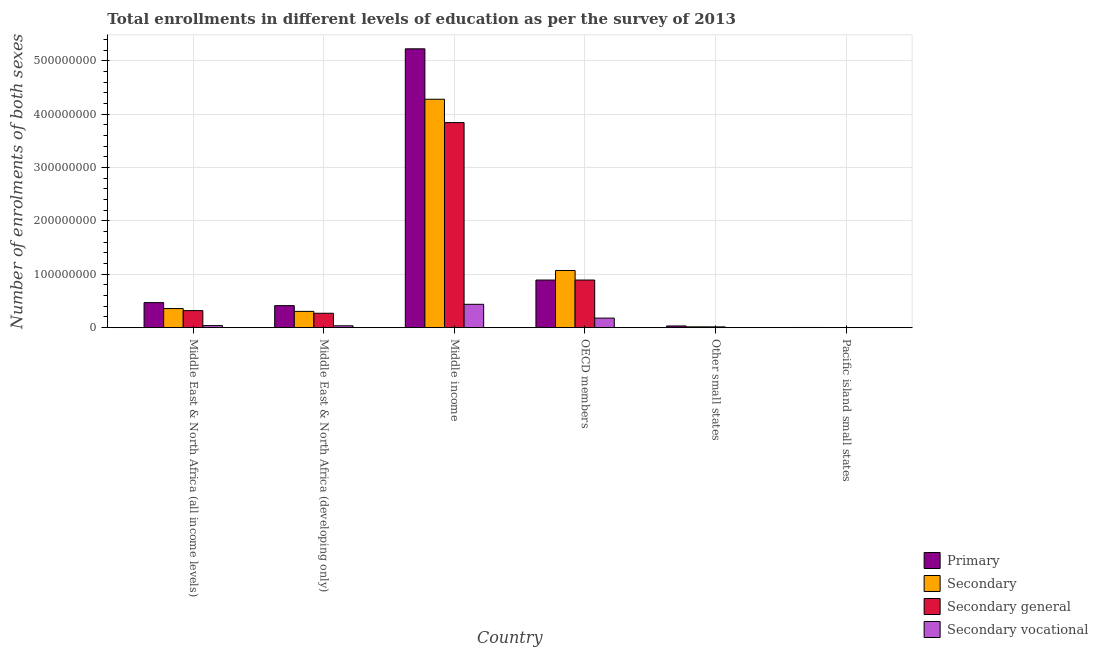Are the number of bars on each tick of the X-axis equal?
Provide a succinct answer. Yes. How many bars are there on the 2nd tick from the right?
Offer a very short reply. 4. In how many cases, is the number of bars for a given country not equal to the number of legend labels?
Offer a very short reply. 0. What is the number of enrolments in secondary vocational education in OECD members?
Ensure brevity in your answer.  1.79e+07. Across all countries, what is the maximum number of enrolments in secondary education?
Offer a very short reply. 4.28e+08. Across all countries, what is the minimum number of enrolments in primary education?
Offer a terse response. 3.38e+05. In which country was the number of enrolments in secondary vocational education maximum?
Your answer should be compact. Middle income. In which country was the number of enrolments in primary education minimum?
Your answer should be very brief. Pacific island small states. What is the total number of enrolments in primary education in the graph?
Offer a very short reply. 7.04e+08. What is the difference between the number of enrolments in secondary general education in Middle East & North Africa (developing only) and that in Middle income?
Provide a succinct answer. -3.57e+08. What is the difference between the number of enrolments in secondary vocational education in Pacific island small states and the number of enrolments in primary education in OECD members?
Your answer should be very brief. -8.93e+07. What is the average number of enrolments in secondary education per country?
Give a very brief answer. 1.01e+08. What is the difference between the number of enrolments in secondary vocational education and number of enrolments in secondary education in Middle East & North Africa (all income levels)?
Keep it short and to the point. -3.20e+07. In how many countries, is the number of enrolments in secondary vocational education greater than 80000000 ?
Your answer should be compact. 0. What is the ratio of the number of enrolments in secondary education in Middle East & North Africa (all income levels) to that in Middle East & North Africa (developing only)?
Your response must be concise. 1.17. Is the difference between the number of enrolments in primary education in Middle East & North Africa (developing only) and Pacific island small states greater than the difference between the number of enrolments in secondary general education in Middle East & North Africa (developing only) and Pacific island small states?
Give a very brief answer. Yes. What is the difference between the highest and the second highest number of enrolments in secondary vocational education?
Offer a very short reply. 2.59e+07. What is the difference between the highest and the lowest number of enrolments in secondary education?
Offer a terse response. 4.28e+08. Is the sum of the number of enrolments in secondary education in Middle East & North Africa (developing only) and Pacific island small states greater than the maximum number of enrolments in secondary vocational education across all countries?
Give a very brief answer. No. What does the 3rd bar from the left in Middle East & North Africa (all income levels) represents?
Provide a succinct answer. Secondary general. What does the 1st bar from the right in Pacific island small states represents?
Offer a terse response. Secondary vocational. Is it the case that in every country, the sum of the number of enrolments in primary education and number of enrolments in secondary education is greater than the number of enrolments in secondary general education?
Your answer should be compact. Yes. What is the difference between two consecutive major ticks on the Y-axis?
Ensure brevity in your answer.  1.00e+08. Are the values on the major ticks of Y-axis written in scientific E-notation?
Provide a succinct answer. No. Does the graph contain any zero values?
Provide a succinct answer. No. Where does the legend appear in the graph?
Provide a succinct answer. Bottom right. How many legend labels are there?
Keep it short and to the point. 4. What is the title of the graph?
Ensure brevity in your answer.  Total enrollments in different levels of education as per the survey of 2013. Does "Miscellaneous expenses" appear as one of the legend labels in the graph?
Your answer should be compact. No. What is the label or title of the X-axis?
Ensure brevity in your answer.  Country. What is the label or title of the Y-axis?
Provide a succinct answer. Number of enrolments of both sexes. What is the Number of enrolments of both sexes in Primary in Middle East & North Africa (all income levels)?
Give a very brief answer. 4.70e+07. What is the Number of enrolments of both sexes of Secondary in Middle East & North Africa (all income levels)?
Your response must be concise. 3.58e+07. What is the Number of enrolments of both sexes in Secondary general in Middle East & North Africa (all income levels)?
Your answer should be compact. 3.20e+07. What is the Number of enrolments of both sexes of Secondary vocational in Middle East & North Africa (all income levels)?
Your answer should be very brief. 3.85e+06. What is the Number of enrolments of both sexes of Primary in Middle East & North Africa (developing only)?
Keep it short and to the point. 4.13e+07. What is the Number of enrolments of both sexes of Secondary in Middle East & North Africa (developing only)?
Provide a succinct answer. 3.05e+07. What is the Number of enrolments of both sexes in Secondary general in Middle East & North Africa (developing only)?
Your answer should be very brief. 2.70e+07. What is the Number of enrolments of both sexes of Secondary vocational in Middle East & North Africa (developing only)?
Your answer should be compact. 3.51e+06. What is the Number of enrolments of both sexes of Primary in Middle income?
Offer a terse response. 5.23e+08. What is the Number of enrolments of both sexes in Secondary in Middle income?
Your answer should be very brief. 4.28e+08. What is the Number of enrolments of both sexes of Secondary general in Middle income?
Your response must be concise. 3.84e+08. What is the Number of enrolments of both sexes in Secondary vocational in Middle income?
Give a very brief answer. 4.38e+07. What is the Number of enrolments of both sexes of Primary in OECD members?
Keep it short and to the point. 8.93e+07. What is the Number of enrolments of both sexes of Secondary in OECD members?
Offer a very short reply. 1.07e+08. What is the Number of enrolments of both sexes in Secondary general in OECD members?
Your answer should be compact. 8.93e+07. What is the Number of enrolments of both sexes of Secondary vocational in OECD members?
Provide a succinct answer. 1.79e+07. What is the Number of enrolments of both sexes in Primary in Other small states?
Your response must be concise. 3.18e+06. What is the Number of enrolments of both sexes of Secondary in Other small states?
Provide a succinct answer. 1.54e+06. What is the Number of enrolments of both sexes of Secondary general in Other small states?
Provide a succinct answer. 1.45e+06. What is the Number of enrolments of both sexes of Secondary vocational in Other small states?
Your answer should be compact. 8.72e+04. What is the Number of enrolments of both sexes in Primary in Pacific island small states?
Keep it short and to the point. 3.38e+05. What is the Number of enrolments of both sexes of Secondary in Pacific island small states?
Your response must be concise. 2.36e+05. What is the Number of enrolments of both sexes of Secondary general in Pacific island small states?
Provide a succinct answer. 2.32e+05. What is the Number of enrolments of both sexes in Secondary vocational in Pacific island small states?
Your answer should be very brief. 4520.05. Across all countries, what is the maximum Number of enrolments of both sexes in Primary?
Your answer should be compact. 5.23e+08. Across all countries, what is the maximum Number of enrolments of both sexes in Secondary?
Your response must be concise. 4.28e+08. Across all countries, what is the maximum Number of enrolments of both sexes in Secondary general?
Your answer should be compact. 3.84e+08. Across all countries, what is the maximum Number of enrolments of both sexes in Secondary vocational?
Offer a very short reply. 4.38e+07. Across all countries, what is the minimum Number of enrolments of both sexes in Primary?
Your answer should be very brief. 3.38e+05. Across all countries, what is the minimum Number of enrolments of both sexes in Secondary?
Keep it short and to the point. 2.36e+05. Across all countries, what is the minimum Number of enrolments of both sexes of Secondary general?
Offer a very short reply. 2.32e+05. Across all countries, what is the minimum Number of enrolments of both sexes in Secondary vocational?
Your response must be concise. 4520.05. What is the total Number of enrolments of both sexes in Primary in the graph?
Your answer should be compact. 7.04e+08. What is the total Number of enrolments of both sexes of Secondary in the graph?
Offer a very short reply. 6.04e+08. What is the total Number of enrolments of both sexes of Secondary general in the graph?
Your answer should be compact. 5.34e+08. What is the total Number of enrolments of both sexes of Secondary vocational in the graph?
Your answer should be very brief. 6.92e+07. What is the difference between the Number of enrolments of both sexes in Primary in Middle East & North Africa (all income levels) and that in Middle East & North Africa (developing only)?
Offer a terse response. 5.65e+06. What is the difference between the Number of enrolments of both sexes in Secondary in Middle East & North Africa (all income levels) and that in Middle East & North Africa (developing only)?
Your answer should be very brief. 5.30e+06. What is the difference between the Number of enrolments of both sexes of Secondary general in Middle East & North Africa (all income levels) and that in Middle East & North Africa (developing only)?
Provide a short and direct response. 4.95e+06. What is the difference between the Number of enrolments of both sexes in Secondary vocational in Middle East & North Africa (all income levels) and that in Middle East & North Africa (developing only)?
Offer a very short reply. 3.45e+05. What is the difference between the Number of enrolments of both sexes in Primary in Middle East & North Africa (all income levels) and that in Middle income?
Your answer should be very brief. -4.76e+08. What is the difference between the Number of enrolments of both sexes of Secondary in Middle East & North Africa (all income levels) and that in Middle income?
Make the answer very short. -3.92e+08. What is the difference between the Number of enrolments of both sexes in Secondary general in Middle East & North Africa (all income levels) and that in Middle income?
Your response must be concise. -3.52e+08. What is the difference between the Number of enrolments of both sexes in Secondary vocational in Middle East & North Africa (all income levels) and that in Middle income?
Provide a succinct answer. -3.99e+07. What is the difference between the Number of enrolments of both sexes in Primary in Middle East & North Africa (all income levels) and that in OECD members?
Keep it short and to the point. -4.23e+07. What is the difference between the Number of enrolments of both sexes in Secondary in Middle East & North Africa (all income levels) and that in OECD members?
Your answer should be compact. -7.14e+07. What is the difference between the Number of enrolments of both sexes of Secondary general in Middle East & North Africa (all income levels) and that in OECD members?
Keep it short and to the point. -5.73e+07. What is the difference between the Number of enrolments of both sexes in Secondary vocational in Middle East & North Africa (all income levels) and that in OECD members?
Your response must be concise. -1.41e+07. What is the difference between the Number of enrolments of both sexes of Primary in Middle East & North Africa (all income levels) and that in Other small states?
Offer a terse response. 4.38e+07. What is the difference between the Number of enrolments of both sexes of Secondary in Middle East & North Africa (all income levels) and that in Other small states?
Make the answer very short. 3.43e+07. What is the difference between the Number of enrolments of both sexes in Secondary general in Middle East & North Africa (all income levels) and that in Other small states?
Your answer should be very brief. 3.05e+07. What is the difference between the Number of enrolments of both sexes in Secondary vocational in Middle East & North Africa (all income levels) and that in Other small states?
Provide a succinct answer. 3.76e+06. What is the difference between the Number of enrolments of both sexes of Primary in Middle East & North Africa (all income levels) and that in Pacific island small states?
Keep it short and to the point. 4.66e+07. What is the difference between the Number of enrolments of both sexes of Secondary in Middle East & North Africa (all income levels) and that in Pacific island small states?
Your response must be concise. 3.56e+07. What is the difference between the Number of enrolments of both sexes of Secondary general in Middle East & North Africa (all income levels) and that in Pacific island small states?
Ensure brevity in your answer.  3.17e+07. What is the difference between the Number of enrolments of both sexes of Secondary vocational in Middle East & North Africa (all income levels) and that in Pacific island small states?
Provide a short and direct response. 3.85e+06. What is the difference between the Number of enrolments of both sexes of Primary in Middle East & North Africa (developing only) and that in Middle income?
Provide a succinct answer. -4.81e+08. What is the difference between the Number of enrolments of both sexes of Secondary in Middle East & North Africa (developing only) and that in Middle income?
Ensure brevity in your answer.  -3.98e+08. What is the difference between the Number of enrolments of both sexes of Secondary general in Middle East & North Africa (developing only) and that in Middle income?
Offer a terse response. -3.57e+08. What is the difference between the Number of enrolments of both sexes of Secondary vocational in Middle East & North Africa (developing only) and that in Middle income?
Your answer should be compact. -4.03e+07. What is the difference between the Number of enrolments of both sexes in Primary in Middle East & North Africa (developing only) and that in OECD members?
Your answer should be very brief. -4.80e+07. What is the difference between the Number of enrolments of both sexes in Secondary in Middle East & North Africa (developing only) and that in OECD members?
Your answer should be very brief. -7.67e+07. What is the difference between the Number of enrolments of both sexes in Secondary general in Middle East & North Africa (developing only) and that in OECD members?
Offer a terse response. -6.23e+07. What is the difference between the Number of enrolments of both sexes in Secondary vocational in Middle East & North Africa (developing only) and that in OECD members?
Offer a very short reply. -1.44e+07. What is the difference between the Number of enrolments of both sexes in Primary in Middle East & North Africa (developing only) and that in Other small states?
Ensure brevity in your answer.  3.81e+07. What is the difference between the Number of enrolments of both sexes in Secondary in Middle East & North Africa (developing only) and that in Other small states?
Offer a very short reply. 2.90e+07. What is the difference between the Number of enrolments of both sexes of Secondary general in Middle East & North Africa (developing only) and that in Other small states?
Your answer should be very brief. 2.56e+07. What is the difference between the Number of enrolments of both sexes of Secondary vocational in Middle East & North Africa (developing only) and that in Other small states?
Your answer should be very brief. 3.42e+06. What is the difference between the Number of enrolments of both sexes in Primary in Middle East & North Africa (developing only) and that in Pacific island small states?
Your response must be concise. 4.10e+07. What is the difference between the Number of enrolments of both sexes of Secondary in Middle East & North Africa (developing only) and that in Pacific island small states?
Ensure brevity in your answer.  3.03e+07. What is the difference between the Number of enrolments of both sexes of Secondary general in Middle East & North Africa (developing only) and that in Pacific island small states?
Offer a terse response. 2.68e+07. What is the difference between the Number of enrolments of both sexes in Secondary vocational in Middle East & North Africa (developing only) and that in Pacific island small states?
Provide a short and direct response. 3.50e+06. What is the difference between the Number of enrolments of both sexes in Primary in Middle income and that in OECD members?
Your response must be concise. 4.33e+08. What is the difference between the Number of enrolments of both sexes in Secondary in Middle income and that in OECD members?
Your answer should be very brief. 3.21e+08. What is the difference between the Number of enrolments of both sexes of Secondary general in Middle income and that in OECD members?
Provide a short and direct response. 2.95e+08. What is the difference between the Number of enrolments of both sexes in Secondary vocational in Middle income and that in OECD members?
Make the answer very short. 2.59e+07. What is the difference between the Number of enrolments of both sexes in Primary in Middle income and that in Other small states?
Make the answer very short. 5.20e+08. What is the difference between the Number of enrolments of both sexes in Secondary in Middle income and that in Other small states?
Keep it short and to the point. 4.27e+08. What is the difference between the Number of enrolments of both sexes of Secondary general in Middle income and that in Other small states?
Ensure brevity in your answer.  3.83e+08. What is the difference between the Number of enrolments of both sexes of Secondary vocational in Middle income and that in Other small states?
Keep it short and to the point. 4.37e+07. What is the difference between the Number of enrolments of both sexes of Primary in Middle income and that in Pacific island small states?
Your answer should be very brief. 5.22e+08. What is the difference between the Number of enrolments of both sexes of Secondary in Middle income and that in Pacific island small states?
Provide a succinct answer. 4.28e+08. What is the difference between the Number of enrolments of both sexes in Secondary general in Middle income and that in Pacific island small states?
Your response must be concise. 3.84e+08. What is the difference between the Number of enrolments of both sexes of Secondary vocational in Middle income and that in Pacific island small states?
Give a very brief answer. 4.38e+07. What is the difference between the Number of enrolments of both sexes of Primary in OECD members and that in Other small states?
Provide a succinct answer. 8.61e+07. What is the difference between the Number of enrolments of both sexes in Secondary in OECD members and that in Other small states?
Your response must be concise. 1.06e+08. What is the difference between the Number of enrolments of both sexes in Secondary general in OECD members and that in Other small states?
Provide a succinct answer. 8.78e+07. What is the difference between the Number of enrolments of both sexes of Secondary vocational in OECD members and that in Other small states?
Ensure brevity in your answer.  1.78e+07. What is the difference between the Number of enrolments of both sexes in Primary in OECD members and that in Pacific island small states?
Give a very brief answer. 8.89e+07. What is the difference between the Number of enrolments of both sexes in Secondary in OECD members and that in Pacific island small states?
Offer a terse response. 1.07e+08. What is the difference between the Number of enrolments of both sexes of Secondary general in OECD members and that in Pacific island small states?
Your answer should be compact. 8.90e+07. What is the difference between the Number of enrolments of both sexes in Secondary vocational in OECD members and that in Pacific island small states?
Provide a succinct answer. 1.79e+07. What is the difference between the Number of enrolments of both sexes in Primary in Other small states and that in Pacific island small states?
Give a very brief answer. 2.85e+06. What is the difference between the Number of enrolments of both sexes of Secondary in Other small states and that in Pacific island small states?
Offer a very short reply. 1.31e+06. What is the difference between the Number of enrolments of both sexes in Secondary general in Other small states and that in Pacific island small states?
Provide a succinct answer. 1.22e+06. What is the difference between the Number of enrolments of both sexes of Secondary vocational in Other small states and that in Pacific island small states?
Give a very brief answer. 8.27e+04. What is the difference between the Number of enrolments of both sexes of Primary in Middle East & North Africa (all income levels) and the Number of enrolments of both sexes of Secondary in Middle East & North Africa (developing only)?
Give a very brief answer. 1.64e+07. What is the difference between the Number of enrolments of both sexes in Primary in Middle East & North Africa (all income levels) and the Number of enrolments of both sexes in Secondary general in Middle East & North Africa (developing only)?
Offer a very short reply. 1.99e+07. What is the difference between the Number of enrolments of both sexes of Primary in Middle East & North Africa (all income levels) and the Number of enrolments of both sexes of Secondary vocational in Middle East & North Africa (developing only)?
Make the answer very short. 4.35e+07. What is the difference between the Number of enrolments of both sexes in Secondary in Middle East & North Africa (all income levels) and the Number of enrolments of both sexes in Secondary general in Middle East & North Africa (developing only)?
Provide a succinct answer. 8.80e+06. What is the difference between the Number of enrolments of both sexes in Secondary in Middle East & North Africa (all income levels) and the Number of enrolments of both sexes in Secondary vocational in Middle East & North Africa (developing only)?
Your response must be concise. 3.23e+07. What is the difference between the Number of enrolments of both sexes in Secondary general in Middle East & North Africa (all income levels) and the Number of enrolments of both sexes in Secondary vocational in Middle East & North Africa (developing only)?
Your response must be concise. 2.85e+07. What is the difference between the Number of enrolments of both sexes in Primary in Middle East & North Africa (all income levels) and the Number of enrolments of both sexes in Secondary in Middle income?
Your answer should be compact. -3.81e+08. What is the difference between the Number of enrolments of both sexes of Primary in Middle East & North Africa (all income levels) and the Number of enrolments of both sexes of Secondary general in Middle income?
Offer a terse response. -3.37e+08. What is the difference between the Number of enrolments of both sexes in Primary in Middle East & North Africa (all income levels) and the Number of enrolments of both sexes in Secondary vocational in Middle income?
Provide a succinct answer. 3.17e+06. What is the difference between the Number of enrolments of both sexes of Secondary in Middle East & North Africa (all income levels) and the Number of enrolments of both sexes of Secondary general in Middle income?
Provide a short and direct response. -3.49e+08. What is the difference between the Number of enrolments of both sexes of Secondary in Middle East & North Africa (all income levels) and the Number of enrolments of both sexes of Secondary vocational in Middle income?
Ensure brevity in your answer.  -7.96e+06. What is the difference between the Number of enrolments of both sexes in Secondary general in Middle East & North Africa (all income levels) and the Number of enrolments of both sexes in Secondary vocational in Middle income?
Provide a succinct answer. -1.18e+07. What is the difference between the Number of enrolments of both sexes in Primary in Middle East & North Africa (all income levels) and the Number of enrolments of both sexes in Secondary in OECD members?
Your answer should be very brief. -6.02e+07. What is the difference between the Number of enrolments of both sexes in Primary in Middle East & North Africa (all income levels) and the Number of enrolments of both sexes in Secondary general in OECD members?
Ensure brevity in your answer.  -4.23e+07. What is the difference between the Number of enrolments of both sexes in Primary in Middle East & North Africa (all income levels) and the Number of enrolments of both sexes in Secondary vocational in OECD members?
Provide a short and direct response. 2.90e+07. What is the difference between the Number of enrolments of both sexes in Secondary in Middle East & North Africa (all income levels) and the Number of enrolments of both sexes in Secondary general in OECD members?
Give a very brief answer. -5.34e+07. What is the difference between the Number of enrolments of both sexes in Secondary in Middle East & North Africa (all income levels) and the Number of enrolments of both sexes in Secondary vocational in OECD members?
Your response must be concise. 1.79e+07. What is the difference between the Number of enrolments of both sexes of Secondary general in Middle East & North Africa (all income levels) and the Number of enrolments of both sexes of Secondary vocational in OECD members?
Offer a terse response. 1.41e+07. What is the difference between the Number of enrolments of both sexes in Primary in Middle East & North Africa (all income levels) and the Number of enrolments of both sexes in Secondary in Other small states?
Your answer should be compact. 4.54e+07. What is the difference between the Number of enrolments of both sexes of Primary in Middle East & North Africa (all income levels) and the Number of enrolments of both sexes of Secondary general in Other small states?
Ensure brevity in your answer.  4.55e+07. What is the difference between the Number of enrolments of both sexes in Primary in Middle East & North Africa (all income levels) and the Number of enrolments of both sexes in Secondary vocational in Other small states?
Make the answer very short. 4.69e+07. What is the difference between the Number of enrolments of both sexes in Secondary in Middle East & North Africa (all income levels) and the Number of enrolments of both sexes in Secondary general in Other small states?
Provide a short and direct response. 3.44e+07. What is the difference between the Number of enrolments of both sexes in Secondary in Middle East & North Africa (all income levels) and the Number of enrolments of both sexes in Secondary vocational in Other small states?
Your answer should be compact. 3.57e+07. What is the difference between the Number of enrolments of both sexes of Secondary general in Middle East & North Africa (all income levels) and the Number of enrolments of both sexes of Secondary vocational in Other small states?
Provide a succinct answer. 3.19e+07. What is the difference between the Number of enrolments of both sexes of Primary in Middle East & North Africa (all income levels) and the Number of enrolments of both sexes of Secondary in Pacific island small states?
Make the answer very short. 4.67e+07. What is the difference between the Number of enrolments of both sexes in Primary in Middle East & North Africa (all income levels) and the Number of enrolments of both sexes in Secondary general in Pacific island small states?
Your answer should be very brief. 4.67e+07. What is the difference between the Number of enrolments of both sexes in Primary in Middle East & North Africa (all income levels) and the Number of enrolments of both sexes in Secondary vocational in Pacific island small states?
Your response must be concise. 4.70e+07. What is the difference between the Number of enrolments of both sexes in Secondary in Middle East & North Africa (all income levels) and the Number of enrolments of both sexes in Secondary general in Pacific island small states?
Offer a terse response. 3.56e+07. What is the difference between the Number of enrolments of both sexes in Secondary in Middle East & North Africa (all income levels) and the Number of enrolments of both sexes in Secondary vocational in Pacific island small states?
Keep it short and to the point. 3.58e+07. What is the difference between the Number of enrolments of both sexes of Secondary general in Middle East & North Africa (all income levels) and the Number of enrolments of both sexes of Secondary vocational in Pacific island small states?
Your answer should be very brief. 3.20e+07. What is the difference between the Number of enrolments of both sexes of Primary in Middle East & North Africa (developing only) and the Number of enrolments of both sexes of Secondary in Middle income?
Provide a short and direct response. -3.87e+08. What is the difference between the Number of enrolments of both sexes in Primary in Middle East & North Africa (developing only) and the Number of enrolments of both sexes in Secondary general in Middle income?
Your response must be concise. -3.43e+08. What is the difference between the Number of enrolments of both sexes in Primary in Middle East & North Africa (developing only) and the Number of enrolments of both sexes in Secondary vocational in Middle income?
Your answer should be very brief. -2.48e+06. What is the difference between the Number of enrolments of both sexes in Secondary in Middle East & North Africa (developing only) and the Number of enrolments of both sexes in Secondary general in Middle income?
Your answer should be very brief. -3.54e+08. What is the difference between the Number of enrolments of both sexes of Secondary in Middle East & North Africa (developing only) and the Number of enrolments of both sexes of Secondary vocational in Middle income?
Give a very brief answer. -1.33e+07. What is the difference between the Number of enrolments of both sexes of Secondary general in Middle East & North Africa (developing only) and the Number of enrolments of both sexes of Secondary vocational in Middle income?
Your answer should be compact. -1.68e+07. What is the difference between the Number of enrolments of both sexes of Primary in Middle East & North Africa (developing only) and the Number of enrolments of both sexes of Secondary in OECD members?
Provide a short and direct response. -6.59e+07. What is the difference between the Number of enrolments of both sexes of Primary in Middle East & North Africa (developing only) and the Number of enrolments of both sexes of Secondary general in OECD members?
Your answer should be compact. -4.80e+07. What is the difference between the Number of enrolments of both sexes in Primary in Middle East & North Africa (developing only) and the Number of enrolments of both sexes in Secondary vocational in OECD members?
Give a very brief answer. 2.34e+07. What is the difference between the Number of enrolments of both sexes of Secondary in Middle East & North Africa (developing only) and the Number of enrolments of both sexes of Secondary general in OECD members?
Give a very brief answer. -5.87e+07. What is the difference between the Number of enrolments of both sexes in Secondary in Middle East & North Africa (developing only) and the Number of enrolments of both sexes in Secondary vocational in OECD members?
Ensure brevity in your answer.  1.26e+07. What is the difference between the Number of enrolments of both sexes of Secondary general in Middle East & North Africa (developing only) and the Number of enrolments of both sexes of Secondary vocational in OECD members?
Provide a short and direct response. 9.10e+06. What is the difference between the Number of enrolments of both sexes of Primary in Middle East & North Africa (developing only) and the Number of enrolments of both sexes of Secondary in Other small states?
Ensure brevity in your answer.  3.98e+07. What is the difference between the Number of enrolments of both sexes in Primary in Middle East & North Africa (developing only) and the Number of enrolments of both sexes in Secondary general in Other small states?
Give a very brief answer. 3.99e+07. What is the difference between the Number of enrolments of both sexes of Primary in Middle East & North Africa (developing only) and the Number of enrolments of both sexes of Secondary vocational in Other small states?
Give a very brief answer. 4.12e+07. What is the difference between the Number of enrolments of both sexes in Secondary in Middle East & North Africa (developing only) and the Number of enrolments of both sexes in Secondary general in Other small states?
Offer a very short reply. 2.91e+07. What is the difference between the Number of enrolments of both sexes of Secondary in Middle East & North Africa (developing only) and the Number of enrolments of both sexes of Secondary vocational in Other small states?
Your response must be concise. 3.04e+07. What is the difference between the Number of enrolments of both sexes of Secondary general in Middle East & North Africa (developing only) and the Number of enrolments of both sexes of Secondary vocational in Other small states?
Provide a short and direct response. 2.69e+07. What is the difference between the Number of enrolments of both sexes of Primary in Middle East & North Africa (developing only) and the Number of enrolments of both sexes of Secondary in Pacific island small states?
Offer a very short reply. 4.11e+07. What is the difference between the Number of enrolments of both sexes in Primary in Middle East & North Africa (developing only) and the Number of enrolments of both sexes in Secondary general in Pacific island small states?
Your answer should be very brief. 4.11e+07. What is the difference between the Number of enrolments of both sexes in Primary in Middle East & North Africa (developing only) and the Number of enrolments of both sexes in Secondary vocational in Pacific island small states?
Offer a terse response. 4.13e+07. What is the difference between the Number of enrolments of both sexes of Secondary in Middle East & North Africa (developing only) and the Number of enrolments of both sexes of Secondary general in Pacific island small states?
Give a very brief answer. 3.03e+07. What is the difference between the Number of enrolments of both sexes of Secondary in Middle East & North Africa (developing only) and the Number of enrolments of both sexes of Secondary vocational in Pacific island small states?
Keep it short and to the point. 3.05e+07. What is the difference between the Number of enrolments of both sexes in Secondary general in Middle East & North Africa (developing only) and the Number of enrolments of both sexes in Secondary vocational in Pacific island small states?
Keep it short and to the point. 2.70e+07. What is the difference between the Number of enrolments of both sexes in Primary in Middle income and the Number of enrolments of both sexes in Secondary in OECD members?
Keep it short and to the point. 4.16e+08. What is the difference between the Number of enrolments of both sexes in Primary in Middle income and the Number of enrolments of both sexes in Secondary general in OECD members?
Your response must be concise. 4.34e+08. What is the difference between the Number of enrolments of both sexes of Primary in Middle income and the Number of enrolments of both sexes of Secondary vocational in OECD members?
Give a very brief answer. 5.05e+08. What is the difference between the Number of enrolments of both sexes in Secondary in Middle income and the Number of enrolments of both sexes in Secondary general in OECD members?
Your response must be concise. 3.39e+08. What is the difference between the Number of enrolments of both sexes of Secondary in Middle income and the Number of enrolments of both sexes of Secondary vocational in OECD members?
Your answer should be very brief. 4.10e+08. What is the difference between the Number of enrolments of both sexes in Secondary general in Middle income and the Number of enrolments of both sexes in Secondary vocational in OECD members?
Offer a terse response. 3.67e+08. What is the difference between the Number of enrolments of both sexes of Primary in Middle income and the Number of enrolments of both sexes of Secondary in Other small states?
Your answer should be compact. 5.21e+08. What is the difference between the Number of enrolments of both sexes of Primary in Middle income and the Number of enrolments of both sexes of Secondary general in Other small states?
Make the answer very short. 5.21e+08. What is the difference between the Number of enrolments of both sexes in Primary in Middle income and the Number of enrolments of both sexes in Secondary vocational in Other small states?
Your response must be concise. 5.23e+08. What is the difference between the Number of enrolments of both sexes of Secondary in Middle income and the Number of enrolments of both sexes of Secondary general in Other small states?
Your answer should be compact. 4.27e+08. What is the difference between the Number of enrolments of both sexes of Secondary in Middle income and the Number of enrolments of both sexes of Secondary vocational in Other small states?
Offer a very short reply. 4.28e+08. What is the difference between the Number of enrolments of both sexes of Secondary general in Middle income and the Number of enrolments of both sexes of Secondary vocational in Other small states?
Provide a short and direct response. 3.84e+08. What is the difference between the Number of enrolments of both sexes in Primary in Middle income and the Number of enrolments of both sexes in Secondary in Pacific island small states?
Keep it short and to the point. 5.23e+08. What is the difference between the Number of enrolments of both sexes in Primary in Middle income and the Number of enrolments of both sexes in Secondary general in Pacific island small states?
Your answer should be compact. 5.23e+08. What is the difference between the Number of enrolments of both sexes in Primary in Middle income and the Number of enrolments of both sexes in Secondary vocational in Pacific island small states?
Make the answer very short. 5.23e+08. What is the difference between the Number of enrolments of both sexes of Secondary in Middle income and the Number of enrolments of both sexes of Secondary general in Pacific island small states?
Your answer should be compact. 4.28e+08. What is the difference between the Number of enrolments of both sexes in Secondary in Middle income and the Number of enrolments of both sexes in Secondary vocational in Pacific island small states?
Provide a succinct answer. 4.28e+08. What is the difference between the Number of enrolments of both sexes in Secondary general in Middle income and the Number of enrolments of both sexes in Secondary vocational in Pacific island small states?
Make the answer very short. 3.84e+08. What is the difference between the Number of enrolments of both sexes in Primary in OECD members and the Number of enrolments of both sexes in Secondary in Other small states?
Offer a terse response. 8.77e+07. What is the difference between the Number of enrolments of both sexes in Primary in OECD members and the Number of enrolments of both sexes in Secondary general in Other small states?
Provide a short and direct response. 8.78e+07. What is the difference between the Number of enrolments of both sexes in Primary in OECD members and the Number of enrolments of both sexes in Secondary vocational in Other small states?
Provide a succinct answer. 8.92e+07. What is the difference between the Number of enrolments of both sexes of Secondary in OECD members and the Number of enrolments of both sexes of Secondary general in Other small states?
Provide a short and direct response. 1.06e+08. What is the difference between the Number of enrolments of both sexes of Secondary in OECD members and the Number of enrolments of both sexes of Secondary vocational in Other small states?
Give a very brief answer. 1.07e+08. What is the difference between the Number of enrolments of both sexes in Secondary general in OECD members and the Number of enrolments of both sexes in Secondary vocational in Other small states?
Offer a very short reply. 8.92e+07. What is the difference between the Number of enrolments of both sexes in Primary in OECD members and the Number of enrolments of both sexes in Secondary in Pacific island small states?
Give a very brief answer. 8.90e+07. What is the difference between the Number of enrolments of both sexes of Primary in OECD members and the Number of enrolments of both sexes of Secondary general in Pacific island small states?
Provide a short and direct response. 8.90e+07. What is the difference between the Number of enrolments of both sexes in Primary in OECD members and the Number of enrolments of both sexes in Secondary vocational in Pacific island small states?
Your answer should be compact. 8.93e+07. What is the difference between the Number of enrolments of both sexes in Secondary in OECD members and the Number of enrolments of both sexes in Secondary general in Pacific island small states?
Provide a succinct answer. 1.07e+08. What is the difference between the Number of enrolments of both sexes in Secondary in OECD members and the Number of enrolments of both sexes in Secondary vocational in Pacific island small states?
Your answer should be compact. 1.07e+08. What is the difference between the Number of enrolments of both sexes of Secondary general in OECD members and the Number of enrolments of both sexes of Secondary vocational in Pacific island small states?
Provide a short and direct response. 8.93e+07. What is the difference between the Number of enrolments of both sexes of Primary in Other small states and the Number of enrolments of both sexes of Secondary in Pacific island small states?
Give a very brief answer. 2.95e+06. What is the difference between the Number of enrolments of both sexes of Primary in Other small states and the Number of enrolments of both sexes of Secondary general in Pacific island small states?
Your answer should be very brief. 2.95e+06. What is the difference between the Number of enrolments of both sexes in Primary in Other small states and the Number of enrolments of both sexes in Secondary vocational in Pacific island small states?
Offer a very short reply. 3.18e+06. What is the difference between the Number of enrolments of both sexes of Secondary in Other small states and the Number of enrolments of both sexes of Secondary general in Pacific island small states?
Ensure brevity in your answer.  1.31e+06. What is the difference between the Number of enrolments of both sexes of Secondary in Other small states and the Number of enrolments of both sexes of Secondary vocational in Pacific island small states?
Provide a succinct answer. 1.54e+06. What is the difference between the Number of enrolments of both sexes in Secondary general in Other small states and the Number of enrolments of both sexes in Secondary vocational in Pacific island small states?
Your answer should be very brief. 1.45e+06. What is the average Number of enrolments of both sexes of Primary per country?
Provide a succinct answer. 1.17e+08. What is the average Number of enrolments of both sexes of Secondary per country?
Provide a short and direct response. 1.01e+08. What is the average Number of enrolments of both sexes in Secondary general per country?
Offer a very short reply. 8.91e+07. What is the average Number of enrolments of both sexes in Secondary vocational per country?
Provide a short and direct response. 1.15e+07. What is the difference between the Number of enrolments of both sexes in Primary and Number of enrolments of both sexes in Secondary in Middle East & North Africa (all income levels)?
Ensure brevity in your answer.  1.11e+07. What is the difference between the Number of enrolments of both sexes of Primary and Number of enrolments of both sexes of Secondary general in Middle East & North Africa (all income levels)?
Make the answer very short. 1.50e+07. What is the difference between the Number of enrolments of both sexes of Primary and Number of enrolments of both sexes of Secondary vocational in Middle East & North Africa (all income levels)?
Offer a terse response. 4.31e+07. What is the difference between the Number of enrolments of both sexes of Secondary and Number of enrolments of both sexes of Secondary general in Middle East & North Africa (all income levels)?
Keep it short and to the point. 3.85e+06. What is the difference between the Number of enrolments of both sexes in Secondary and Number of enrolments of both sexes in Secondary vocational in Middle East & North Africa (all income levels)?
Provide a succinct answer. 3.20e+07. What is the difference between the Number of enrolments of both sexes in Secondary general and Number of enrolments of both sexes in Secondary vocational in Middle East & North Africa (all income levels)?
Your answer should be very brief. 2.81e+07. What is the difference between the Number of enrolments of both sexes in Primary and Number of enrolments of both sexes in Secondary in Middle East & North Africa (developing only)?
Provide a succinct answer. 1.08e+07. What is the difference between the Number of enrolments of both sexes in Primary and Number of enrolments of both sexes in Secondary general in Middle East & North Africa (developing only)?
Give a very brief answer. 1.43e+07. What is the difference between the Number of enrolments of both sexes of Primary and Number of enrolments of both sexes of Secondary vocational in Middle East & North Africa (developing only)?
Offer a terse response. 3.78e+07. What is the difference between the Number of enrolments of both sexes of Secondary and Number of enrolments of both sexes of Secondary general in Middle East & North Africa (developing only)?
Offer a terse response. 3.51e+06. What is the difference between the Number of enrolments of both sexes in Secondary and Number of enrolments of both sexes in Secondary vocational in Middle East & North Africa (developing only)?
Provide a succinct answer. 2.70e+07. What is the difference between the Number of enrolments of both sexes in Secondary general and Number of enrolments of both sexes in Secondary vocational in Middle East & North Africa (developing only)?
Ensure brevity in your answer.  2.35e+07. What is the difference between the Number of enrolments of both sexes of Primary and Number of enrolments of both sexes of Secondary in Middle income?
Your answer should be very brief. 9.45e+07. What is the difference between the Number of enrolments of both sexes in Primary and Number of enrolments of both sexes in Secondary general in Middle income?
Offer a terse response. 1.38e+08. What is the difference between the Number of enrolments of both sexes of Primary and Number of enrolments of both sexes of Secondary vocational in Middle income?
Ensure brevity in your answer.  4.79e+08. What is the difference between the Number of enrolments of both sexes in Secondary and Number of enrolments of both sexes in Secondary general in Middle income?
Your answer should be compact. 4.38e+07. What is the difference between the Number of enrolments of both sexes of Secondary and Number of enrolments of both sexes of Secondary vocational in Middle income?
Provide a short and direct response. 3.84e+08. What is the difference between the Number of enrolments of both sexes in Secondary general and Number of enrolments of both sexes in Secondary vocational in Middle income?
Keep it short and to the point. 3.41e+08. What is the difference between the Number of enrolments of both sexes in Primary and Number of enrolments of both sexes in Secondary in OECD members?
Offer a very short reply. -1.79e+07. What is the difference between the Number of enrolments of both sexes in Primary and Number of enrolments of both sexes in Secondary general in OECD members?
Ensure brevity in your answer.  3752. What is the difference between the Number of enrolments of both sexes of Primary and Number of enrolments of both sexes of Secondary vocational in OECD members?
Your response must be concise. 7.14e+07. What is the difference between the Number of enrolments of both sexes in Secondary and Number of enrolments of both sexes in Secondary general in OECD members?
Offer a terse response. 1.79e+07. What is the difference between the Number of enrolments of both sexes in Secondary and Number of enrolments of both sexes in Secondary vocational in OECD members?
Your answer should be very brief. 8.93e+07. What is the difference between the Number of enrolments of both sexes of Secondary general and Number of enrolments of both sexes of Secondary vocational in OECD members?
Your response must be concise. 7.14e+07. What is the difference between the Number of enrolments of both sexes of Primary and Number of enrolments of both sexes of Secondary in Other small states?
Make the answer very short. 1.64e+06. What is the difference between the Number of enrolments of both sexes of Primary and Number of enrolments of both sexes of Secondary general in Other small states?
Offer a very short reply. 1.73e+06. What is the difference between the Number of enrolments of both sexes of Primary and Number of enrolments of both sexes of Secondary vocational in Other small states?
Provide a short and direct response. 3.10e+06. What is the difference between the Number of enrolments of both sexes of Secondary and Number of enrolments of both sexes of Secondary general in Other small states?
Your response must be concise. 8.72e+04. What is the difference between the Number of enrolments of both sexes of Secondary and Number of enrolments of both sexes of Secondary vocational in Other small states?
Give a very brief answer. 1.45e+06. What is the difference between the Number of enrolments of both sexes of Secondary general and Number of enrolments of both sexes of Secondary vocational in Other small states?
Ensure brevity in your answer.  1.37e+06. What is the difference between the Number of enrolments of both sexes in Primary and Number of enrolments of both sexes in Secondary in Pacific island small states?
Give a very brief answer. 1.02e+05. What is the difference between the Number of enrolments of both sexes of Primary and Number of enrolments of both sexes of Secondary general in Pacific island small states?
Your answer should be compact. 1.06e+05. What is the difference between the Number of enrolments of both sexes of Primary and Number of enrolments of both sexes of Secondary vocational in Pacific island small states?
Keep it short and to the point. 3.34e+05. What is the difference between the Number of enrolments of both sexes in Secondary and Number of enrolments of both sexes in Secondary general in Pacific island small states?
Keep it short and to the point. 4520.06. What is the difference between the Number of enrolments of both sexes in Secondary and Number of enrolments of both sexes in Secondary vocational in Pacific island small states?
Your answer should be very brief. 2.32e+05. What is the difference between the Number of enrolments of both sexes of Secondary general and Number of enrolments of both sexes of Secondary vocational in Pacific island small states?
Your answer should be compact. 2.27e+05. What is the ratio of the Number of enrolments of both sexes of Primary in Middle East & North Africa (all income levels) to that in Middle East & North Africa (developing only)?
Make the answer very short. 1.14. What is the ratio of the Number of enrolments of both sexes in Secondary in Middle East & North Africa (all income levels) to that in Middle East & North Africa (developing only)?
Your answer should be compact. 1.17. What is the ratio of the Number of enrolments of both sexes of Secondary general in Middle East & North Africa (all income levels) to that in Middle East & North Africa (developing only)?
Offer a very short reply. 1.18. What is the ratio of the Number of enrolments of both sexes of Secondary vocational in Middle East & North Africa (all income levels) to that in Middle East & North Africa (developing only)?
Offer a terse response. 1.1. What is the ratio of the Number of enrolments of both sexes in Primary in Middle East & North Africa (all income levels) to that in Middle income?
Your answer should be compact. 0.09. What is the ratio of the Number of enrolments of both sexes of Secondary in Middle East & North Africa (all income levels) to that in Middle income?
Offer a terse response. 0.08. What is the ratio of the Number of enrolments of both sexes in Secondary general in Middle East & North Africa (all income levels) to that in Middle income?
Offer a very short reply. 0.08. What is the ratio of the Number of enrolments of both sexes in Secondary vocational in Middle East & North Africa (all income levels) to that in Middle income?
Your answer should be compact. 0.09. What is the ratio of the Number of enrolments of both sexes in Primary in Middle East & North Africa (all income levels) to that in OECD members?
Ensure brevity in your answer.  0.53. What is the ratio of the Number of enrolments of both sexes of Secondary in Middle East & North Africa (all income levels) to that in OECD members?
Keep it short and to the point. 0.33. What is the ratio of the Number of enrolments of both sexes in Secondary general in Middle East & North Africa (all income levels) to that in OECD members?
Provide a succinct answer. 0.36. What is the ratio of the Number of enrolments of both sexes of Secondary vocational in Middle East & North Africa (all income levels) to that in OECD members?
Provide a succinct answer. 0.21. What is the ratio of the Number of enrolments of both sexes in Primary in Middle East & North Africa (all income levels) to that in Other small states?
Offer a terse response. 14.75. What is the ratio of the Number of enrolments of both sexes of Secondary in Middle East & North Africa (all income levels) to that in Other small states?
Ensure brevity in your answer.  23.24. What is the ratio of the Number of enrolments of both sexes of Secondary general in Middle East & North Africa (all income levels) to that in Other small states?
Make the answer very short. 21.98. What is the ratio of the Number of enrolments of both sexes in Secondary vocational in Middle East & North Africa (all income levels) to that in Other small states?
Your answer should be very brief. 44.15. What is the ratio of the Number of enrolments of both sexes of Primary in Middle East & North Africa (all income levels) to that in Pacific island small states?
Keep it short and to the point. 138.82. What is the ratio of the Number of enrolments of both sexes in Secondary in Middle East & North Africa (all income levels) to that in Pacific island small states?
Ensure brevity in your answer.  151.51. What is the ratio of the Number of enrolments of both sexes in Secondary general in Middle East & North Africa (all income levels) to that in Pacific island small states?
Ensure brevity in your answer.  137.85. What is the ratio of the Number of enrolments of both sexes in Secondary vocational in Middle East & North Africa (all income levels) to that in Pacific island small states?
Your response must be concise. 852.06. What is the ratio of the Number of enrolments of both sexes in Primary in Middle East & North Africa (developing only) to that in Middle income?
Your response must be concise. 0.08. What is the ratio of the Number of enrolments of both sexes in Secondary in Middle East & North Africa (developing only) to that in Middle income?
Your answer should be compact. 0.07. What is the ratio of the Number of enrolments of both sexes of Secondary general in Middle East & North Africa (developing only) to that in Middle income?
Ensure brevity in your answer.  0.07. What is the ratio of the Number of enrolments of both sexes in Secondary vocational in Middle East & North Africa (developing only) to that in Middle income?
Your answer should be very brief. 0.08. What is the ratio of the Number of enrolments of both sexes of Primary in Middle East & North Africa (developing only) to that in OECD members?
Offer a terse response. 0.46. What is the ratio of the Number of enrolments of both sexes in Secondary in Middle East & North Africa (developing only) to that in OECD members?
Your response must be concise. 0.28. What is the ratio of the Number of enrolments of both sexes of Secondary general in Middle East & North Africa (developing only) to that in OECD members?
Your response must be concise. 0.3. What is the ratio of the Number of enrolments of both sexes of Secondary vocational in Middle East & North Africa (developing only) to that in OECD members?
Provide a succinct answer. 0.2. What is the ratio of the Number of enrolments of both sexes of Primary in Middle East & North Africa (developing only) to that in Other small states?
Ensure brevity in your answer.  12.97. What is the ratio of the Number of enrolments of both sexes of Secondary in Middle East & North Africa (developing only) to that in Other small states?
Ensure brevity in your answer.  19.8. What is the ratio of the Number of enrolments of both sexes in Secondary general in Middle East & North Africa (developing only) to that in Other small states?
Ensure brevity in your answer.  18.58. What is the ratio of the Number of enrolments of both sexes of Secondary vocational in Middle East & North Africa (developing only) to that in Other small states?
Make the answer very short. 40.19. What is the ratio of the Number of enrolments of both sexes in Primary in Middle East & North Africa (developing only) to that in Pacific island small states?
Provide a short and direct response. 122.12. What is the ratio of the Number of enrolments of both sexes of Secondary in Middle East & North Africa (developing only) to that in Pacific island small states?
Provide a short and direct response. 129.1. What is the ratio of the Number of enrolments of both sexes in Secondary general in Middle East & North Africa (developing only) to that in Pacific island small states?
Provide a short and direct response. 116.5. What is the ratio of the Number of enrolments of both sexes in Secondary vocational in Middle East & North Africa (developing only) to that in Pacific island small states?
Make the answer very short. 775.63. What is the ratio of the Number of enrolments of both sexes in Primary in Middle income to that in OECD members?
Your answer should be very brief. 5.86. What is the ratio of the Number of enrolments of both sexes in Secondary in Middle income to that in OECD members?
Offer a very short reply. 4. What is the ratio of the Number of enrolments of both sexes of Secondary general in Middle income to that in OECD members?
Your response must be concise. 4.31. What is the ratio of the Number of enrolments of both sexes of Secondary vocational in Middle income to that in OECD members?
Give a very brief answer. 2.44. What is the ratio of the Number of enrolments of both sexes in Primary in Middle income to that in Other small states?
Your response must be concise. 164.18. What is the ratio of the Number of enrolments of both sexes of Secondary in Middle income to that in Other small states?
Keep it short and to the point. 277.79. What is the ratio of the Number of enrolments of both sexes of Secondary general in Middle income to that in Other small states?
Your answer should be compact. 264.35. What is the ratio of the Number of enrolments of both sexes of Secondary vocational in Middle income to that in Other small states?
Provide a short and direct response. 501.87. What is the ratio of the Number of enrolments of both sexes of Primary in Middle income to that in Pacific island small states?
Offer a very short reply. 1545.54. What is the ratio of the Number of enrolments of both sexes of Secondary in Middle income to that in Pacific island small states?
Provide a short and direct response. 1811.15. What is the ratio of the Number of enrolments of both sexes in Secondary general in Middle income to that in Pacific island small states?
Make the answer very short. 1657.67. What is the ratio of the Number of enrolments of both sexes of Secondary vocational in Middle income to that in Pacific island small states?
Your answer should be compact. 9686.39. What is the ratio of the Number of enrolments of both sexes of Primary in OECD members to that in Other small states?
Your answer should be very brief. 28.04. What is the ratio of the Number of enrolments of both sexes in Secondary in OECD members to that in Other small states?
Ensure brevity in your answer.  69.53. What is the ratio of the Number of enrolments of both sexes of Secondary general in OECD members to that in Other small states?
Your response must be concise. 61.38. What is the ratio of the Number of enrolments of both sexes in Secondary vocational in OECD members to that in Other small states?
Provide a short and direct response. 205.4. What is the ratio of the Number of enrolments of both sexes of Primary in OECD members to that in Pacific island small states?
Your response must be concise. 263.94. What is the ratio of the Number of enrolments of both sexes in Secondary in OECD members to that in Pacific island small states?
Keep it short and to the point. 453.34. What is the ratio of the Number of enrolments of both sexes of Secondary general in OECD members to that in Pacific island small states?
Offer a terse response. 384.92. What is the ratio of the Number of enrolments of both sexes in Secondary vocational in OECD members to that in Pacific island small states?
Ensure brevity in your answer.  3964.41. What is the ratio of the Number of enrolments of both sexes in Primary in Other small states to that in Pacific island small states?
Keep it short and to the point. 9.41. What is the ratio of the Number of enrolments of both sexes of Secondary in Other small states to that in Pacific island small states?
Make the answer very short. 6.52. What is the ratio of the Number of enrolments of both sexes of Secondary general in Other small states to that in Pacific island small states?
Your response must be concise. 6.27. What is the ratio of the Number of enrolments of both sexes of Secondary vocational in Other small states to that in Pacific island small states?
Your answer should be very brief. 19.3. What is the difference between the highest and the second highest Number of enrolments of both sexes in Primary?
Your answer should be compact. 4.33e+08. What is the difference between the highest and the second highest Number of enrolments of both sexes of Secondary?
Offer a very short reply. 3.21e+08. What is the difference between the highest and the second highest Number of enrolments of both sexes in Secondary general?
Provide a succinct answer. 2.95e+08. What is the difference between the highest and the second highest Number of enrolments of both sexes of Secondary vocational?
Offer a terse response. 2.59e+07. What is the difference between the highest and the lowest Number of enrolments of both sexes in Primary?
Offer a terse response. 5.22e+08. What is the difference between the highest and the lowest Number of enrolments of both sexes in Secondary?
Ensure brevity in your answer.  4.28e+08. What is the difference between the highest and the lowest Number of enrolments of both sexes in Secondary general?
Offer a terse response. 3.84e+08. What is the difference between the highest and the lowest Number of enrolments of both sexes of Secondary vocational?
Keep it short and to the point. 4.38e+07. 